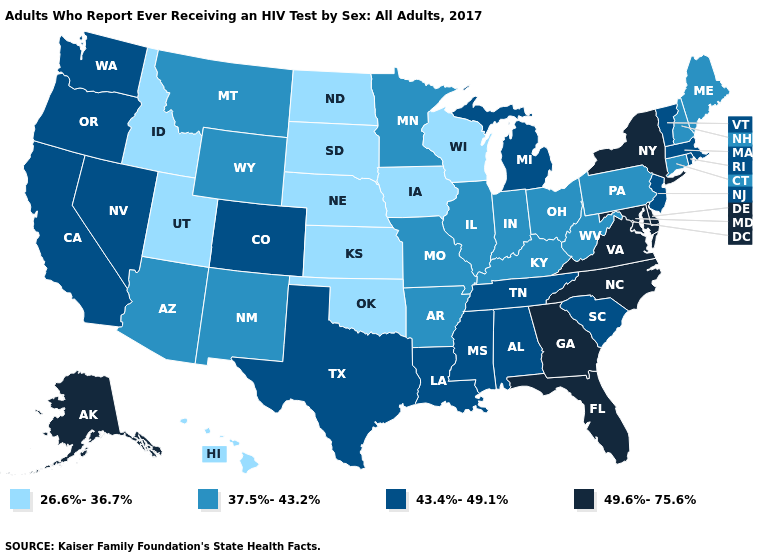What is the highest value in the USA?
Write a very short answer. 49.6%-75.6%. Which states hav the highest value in the MidWest?
Be succinct. Michigan. What is the highest value in the USA?
Write a very short answer. 49.6%-75.6%. What is the highest value in the USA?
Give a very brief answer. 49.6%-75.6%. Does Alaska have the highest value in the West?
Answer briefly. Yes. Name the states that have a value in the range 26.6%-36.7%?
Be succinct. Hawaii, Idaho, Iowa, Kansas, Nebraska, North Dakota, Oklahoma, South Dakota, Utah, Wisconsin. What is the value of Kentucky?
Keep it brief. 37.5%-43.2%. What is the highest value in the USA?
Short answer required. 49.6%-75.6%. Among the states that border Oklahoma , which have the lowest value?
Short answer required. Kansas. How many symbols are there in the legend?
Concise answer only. 4. How many symbols are there in the legend?
Keep it brief. 4. What is the value of Kentucky?
Quick response, please. 37.5%-43.2%. Name the states that have a value in the range 26.6%-36.7%?
Short answer required. Hawaii, Idaho, Iowa, Kansas, Nebraska, North Dakota, Oklahoma, South Dakota, Utah, Wisconsin. Name the states that have a value in the range 26.6%-36.7%?
Keep it brief. Hawaii, Idaho, Iowa, Kansas, Nebraska, North Dakota, Oklahoma, South Dakota, Utah, Wisconsin. What is the highest value in the Northeast ?
Write a very short answer. 49.6%-75.6%. 